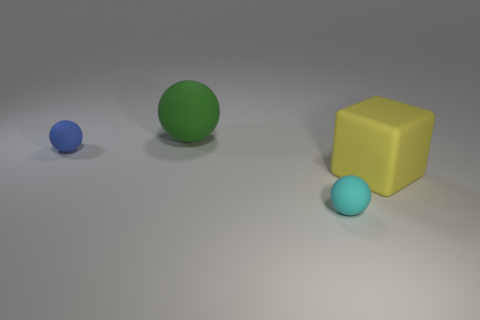Is the shape of the small thing behind the cyan ball the same as  the cyan matte thing?
Ensure brevity in your answer.  Yes. The matte block has what color?
Keep it short and to the point. Yellow. Are any tiny cyan matte spheres visible?
Offer a very short reply. Yes. What is the size of the green thing that is the same material as the large yellow cube?
Provide a short and direct response. Large. There is a matte object to the right of the small object in front of the large object in front of the green sphere; what is its shape?
Offer a very short reply. Cube. Are there the same number of small cyan balls that are right of the tiny blue thing and small balls?
Give a very brief answer. No. Is the small cyan rubber object the same shape as the yellow matte object?
Your answer should be very brief. No. How many things are tiny matte spheres in front of the large cube or blue balls?
Provide a short and direct response. 2. Is the number of big blocks to the left of the cyan ball the same as the number of cyan matte balls that are left of the green rubber ball?
Your answer should be very brief. Yes. How many other things are there of the same shape as the small cyan rubber thing?
Offer a very short reply. 2. 